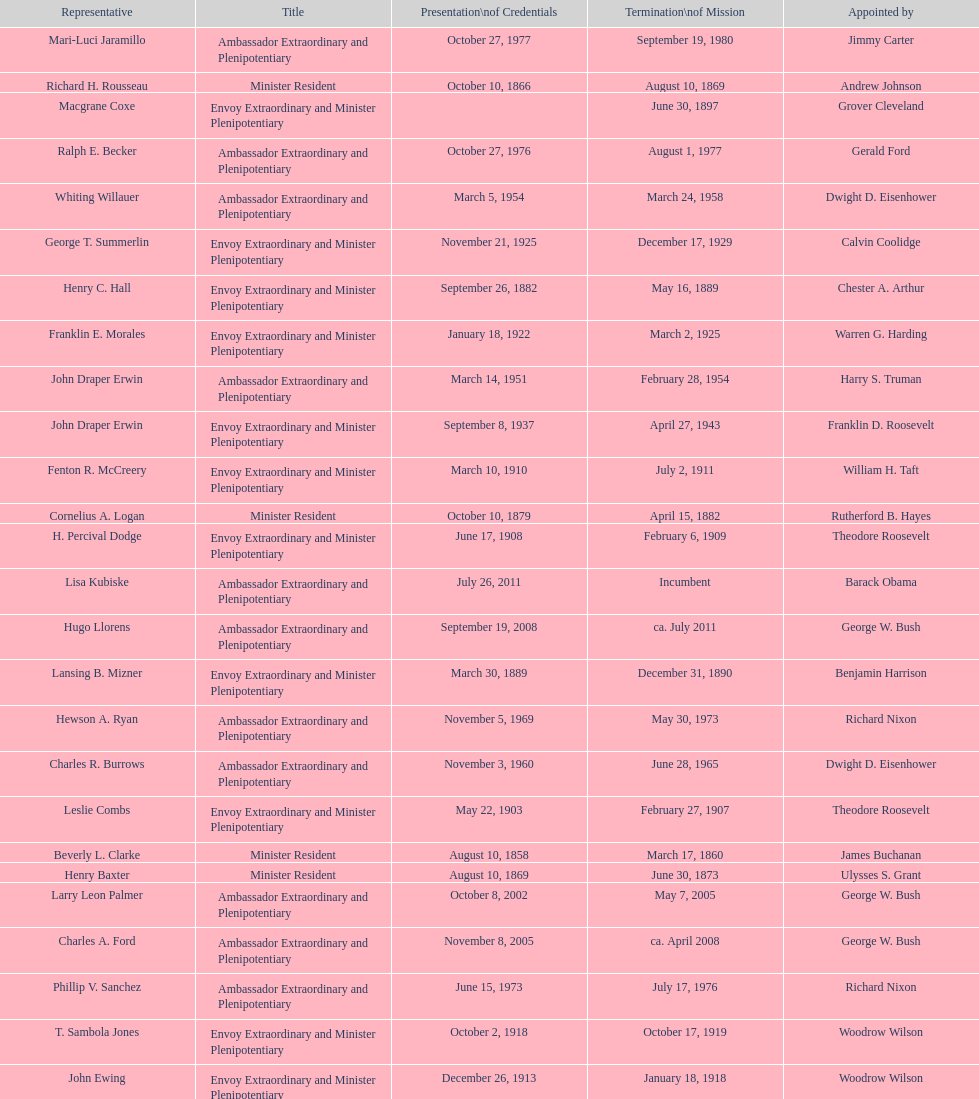How many representatives were appointed by theodore roosevelt? 4. 